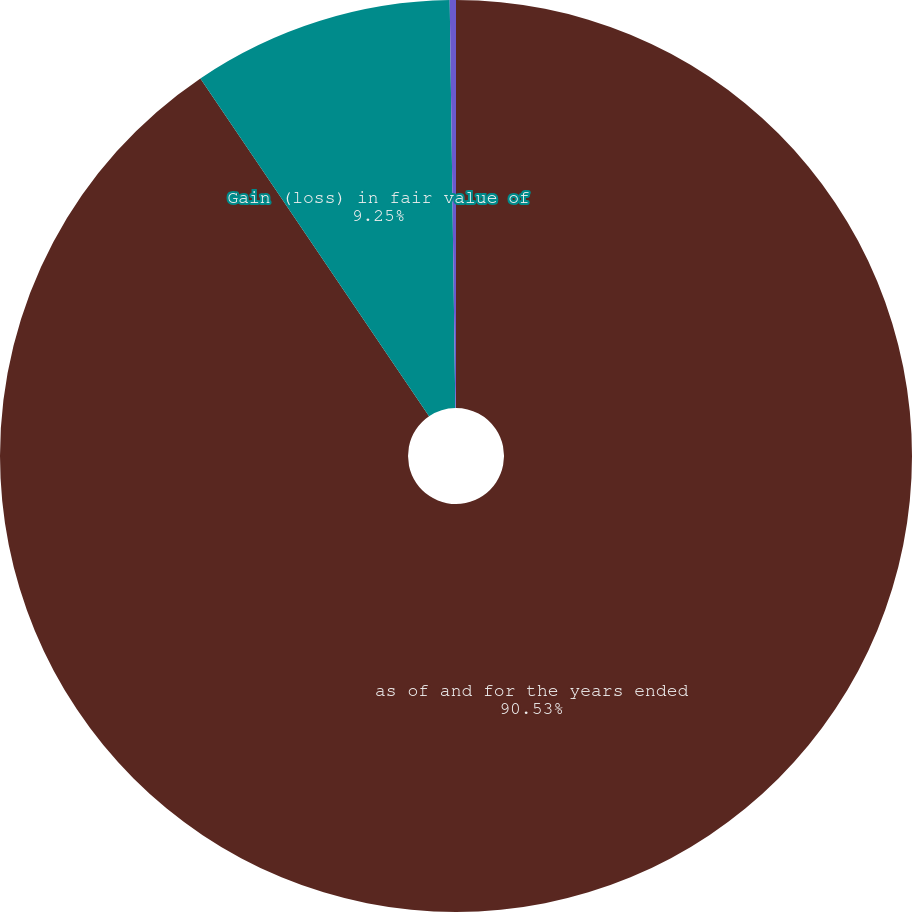Convert chart to OTSL. <chart><loc_0><loc_0><loc_500><loc_500><pie_chart><fcel>as of and for the years ended<fcel>Gain (loss) in fair value of<fcel>Accumulated other<nl><fcel>90.52%<fcel>9.25%<fcel>0.22%<nl></chart> 